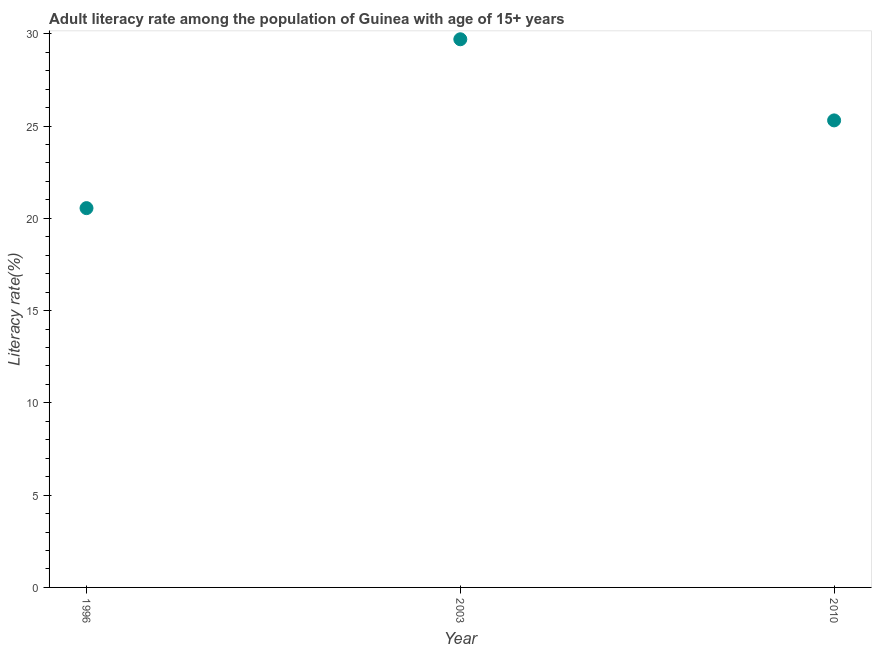What is the adult literacy rate in 2010?
Ensure brevity in your answer.  25.31. Across all years, what is the maximum adult literacy rate?
Provide a short and direct response. 29.7. Across all years, what is the minimum adult literacy rate?
Ensure brevity in your answer.  20.55. In which year was the adult literacy rate minimum?
Make the answer very short. 1996. What is the sum of the adult literacy rate?
Provide a short and direct response. 75.57. What is the difference between the adult literacy rate in 1996 and 2003?
Your answer should be very brief. -9.15. What is the average adult literacy rate per year?
Provide a short and direct response. 25.19. What is the median adult literacy rate?
Your answer should be very brief. 25.31. What is the ratio of the adult literacy rate in 1996 to that in 2003?
Your response must be concise. 0.69. What is the difference between the highest and the second highest adult literacy rate?
Ensure brevity in your answer.  4.4. Is the sum of the adult literacy rate in 2003 and 2010 greater than the maximum adult literacy rate across all years?
Make the answer very short. Yes. What is the difference between the highest and the lowest adult literacy rate?
Offer a terse response. 9.15. Does the adult literacy rate monotonically increase over the years?
Provide a short and direct response. No. What is the difference between two consecutive major ticks on the Y-axis?
Ensure brevity in your answer.  5. Does the graph contain any zero values?
Your answer should be compact. No. Does the graph contain grids?
Your response must be concise. No. What is the title of the graph?
Make the answer very short. Adult literacy rate among the population of Guinea with age of 15+ years. What is the label or title of the X-axis?
Your response must be concise. Year. What is the label or title of the Y-axis?
Keep it short and to the point. Literacy rate(%). What is the Literacy rate(%) in 1996?
Give a very brief answer. 20.55. What is the Literacy rate(%) in 2003?
Provide a succinct answer. 29.7. What is the Literacy rate(%) in 2010?
Keep it short and to the point. 25.31. What is the difference between the Literacy rate(%) in 1996 and 2003?
Give a very brief answer. -9.15. What is the difference between the Literacy rate(%) in 1996 and 2010?
Keep it short and to the point. -4.75. What is the difference between the Literacy rate(%) in 2003 and 2010?
Keep it short and to the point. 4.4. What is the ratio of the Literacy rate(%) in 1996 to that in 2003?
Ensure brevity in your answer.  0.69. What is the ratio of the Literacy rate(%) in 1996 to that in 2010?
Keep it short and to the point. 0.81. What is the ratio of the Literacy rate(%) in 2003 to that in 2010?
Keep it short and to the point. 1.17. 